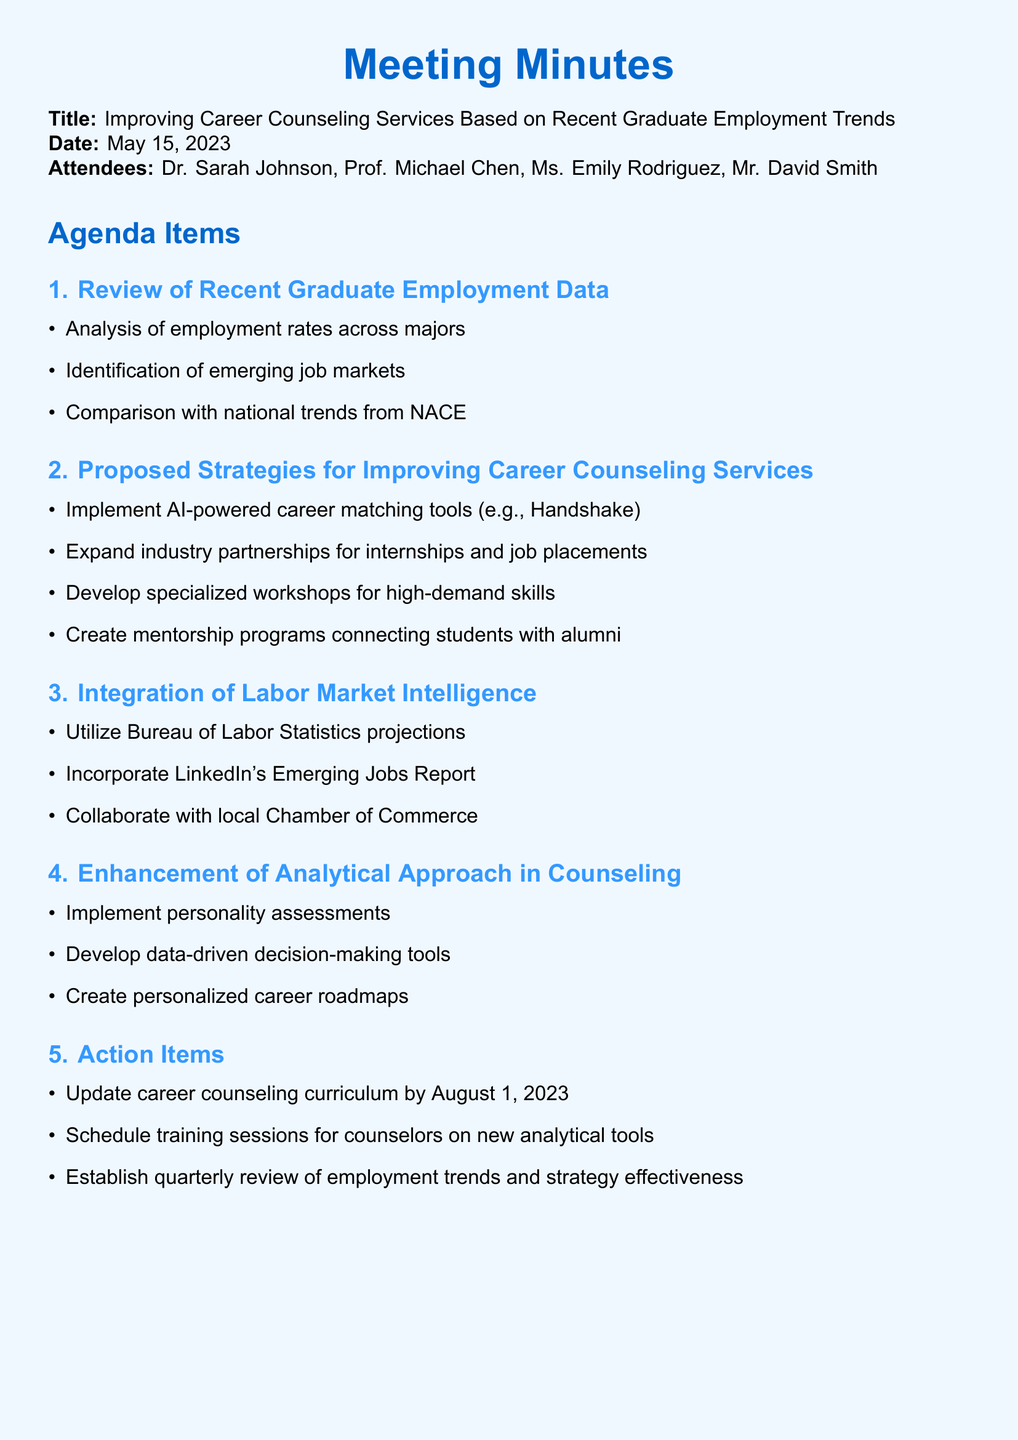What is the meeting title? The meeting title is stated at the top of the document as "Improving Career Counseling Services Based on Recent Graduate Employment Trends."
Answer: Improving Career Counseling Services Based on Recent Graduate Employment Trends Who led the meeting? The lead college counselor, Dr. Sarah Johnson, is mentioned as the person leading the meeting.
Answer: Dr. Sarah Johnson When was the meeting held? The date of the meeting is clearly noted in the document as May 15, 2023.
Answer: May 15, 2023 What is one of the proposed strategies for improving career counseling services? The strategies discussed include several points; one such point is the implementation of AI-powered career matching tools.
Answer: Implement AI-powered career matching tools How many attendees were present at the meeting? The number of attendees is indicated by the list provided, which includes four people.
Answer: Four What analytical tools are planned for training sessions? The document mentions scheduling training sessions for counselors on new analytical tools, but it does not specify which ones.
Answer: New analytical tools What type of assessments will be implemented in counseling? It is noted that personality assessments, like Myers-Briggs or CliftonStrengths, will be incorporated into the counseling process.
Answer: Personality assessments What is one action item agreed upon during the meeting? The document lists several action items, one of which is to update the career counseling curriculum by a specific date.
Answer: Update career counseling curriculum by August 1, 2023 Which organization's projections are to be utilized for career guidance? The document specifies using the Bureau of Labor Statistics projections for guidance on career options.
Answer: Bureau of Labor Statistics 